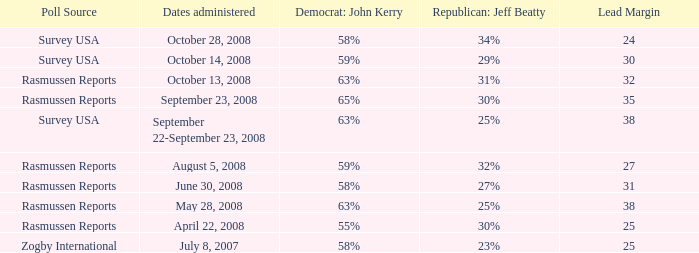As per rasmussen reports, what percentage does the 25-point lead margin of republican jeff beatty represent? 30%. 